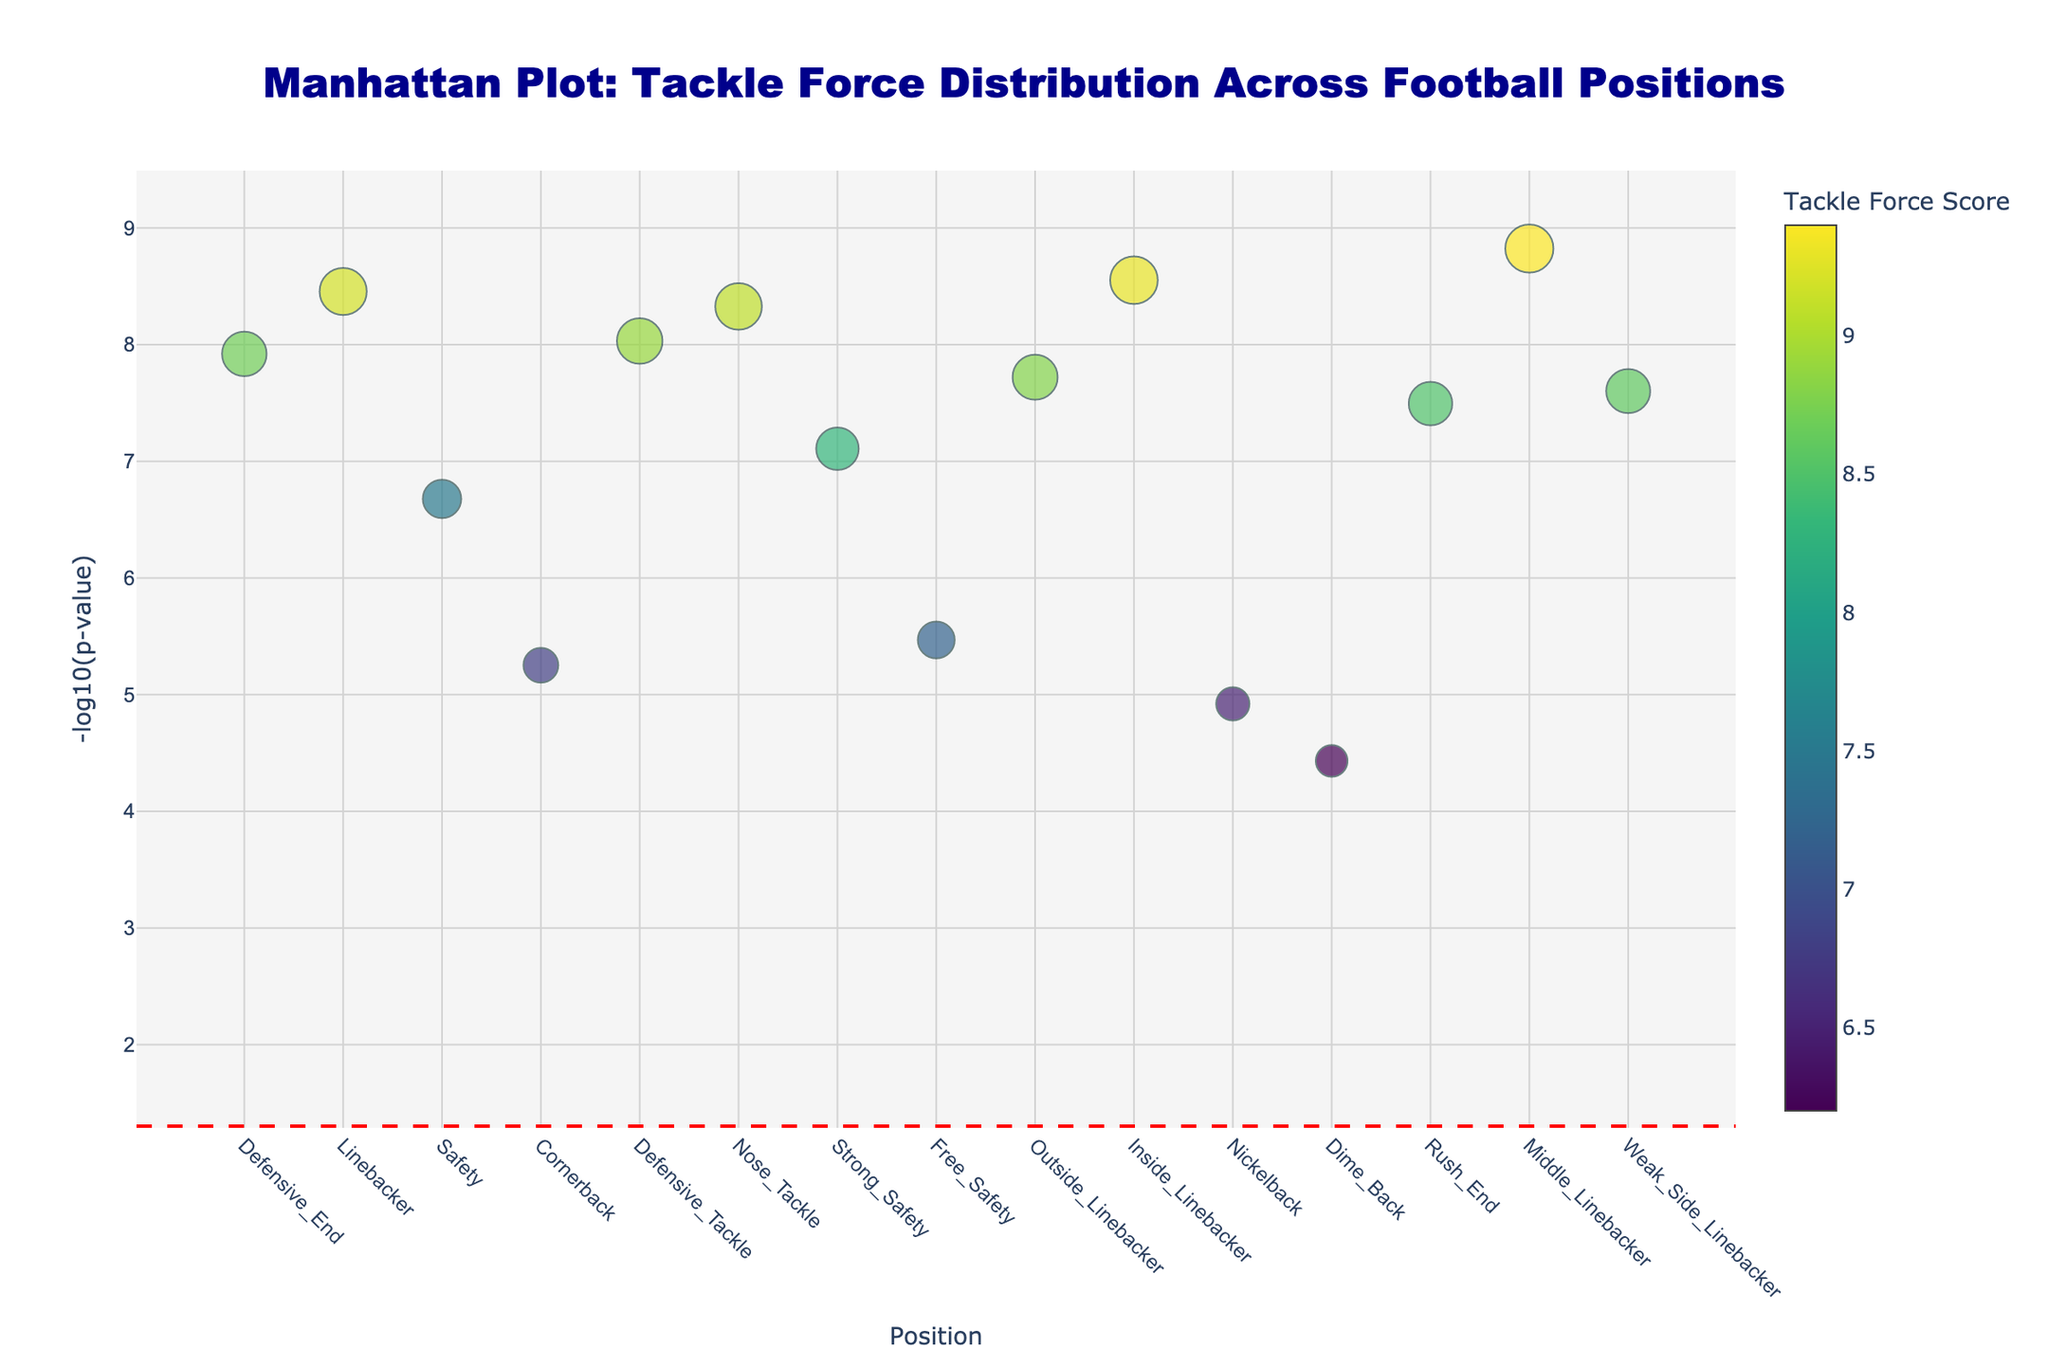What is the title of the plot? Look at the top of the plot where the title is displayed. The title is in large font and centered at the top.
Answer: Manhattan Plot: Tackle Force Distribution Across Football Positions Which position has the highest -log10(p-value)? Examine the y-axis to find the tallest marker, then trace down to the x-axis to identify the position.
Answer: Middle_Linebacker How many positions have a Tackle Force Score of 8.7 or above? Identify markers with sizes correlating to a Tackle Force Score of 8.7 or above and count them.
Answer: 10 What color represents the highest Tackle Force Score on the color scale? Look at the color bar on the right to see which color corresponds with the highest Tackle Force Score.
Answer: Yellow How many data points fall below the significance threshold line? Count the number of markers positioned below the horizontal red dash line representing the -log10(p-value) of 0.05.
Answer: 0 Which position has the lowest -log10(p-value)? Find the shortest marker on the y-axis and trace back to the x-axis to identify the position.
Answer: Dime_Back What is the average Tackle Force Score of the positions with -log10(p-values) greater than 7? Identify positions with markers above the 7 on y-axis, sum their Tackle Force Scores and divide by their count. (8.7+9.2+8.9+9.1+8.3+8.8+9.3+9.4+8.6) / 9 = 8.92
Answer: 8.92 Which positions have both the Tackle Force Score and the -log10(p-value) in the lower half of this plot? Look for markers positioned below the median lines for both Tackle Force Score and -log10(p-value), indicating their values are in the lower half range.
Answer: Cornerback, Nickelback, Dime_Back What is the difference in Tackle Force Score between the positions with the highest and lowest -log10(p-value)? Find the Tackle Force Scores for Middle_Linebacker (highest) and Dime_Back (lowest); then subtract. 9.4 - 6.2
Answer: 3.2 